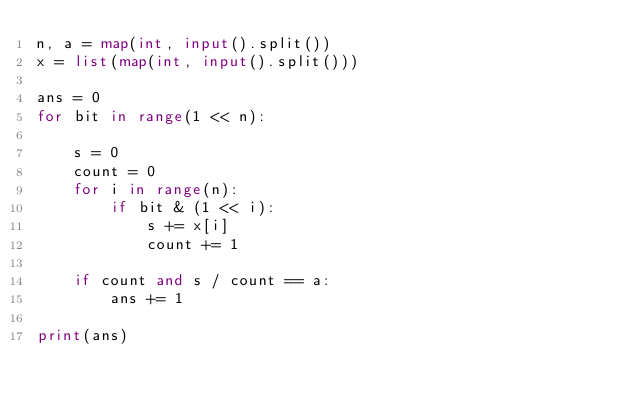Convert code to text. <code><loc_0><loc_0><loc_500><loc_500><_Python_>n, a = map(int, input().split())
x = list(map(int, input().split()))

ans = 0
for bit in range(1 << n):

    s = 0
    count = 0
    for i in range(n):
        if bit & (1 << i):
            s += x[i]
            count += 1

    if count and s / count == a:
        ans += 1

print(ans)</code> 